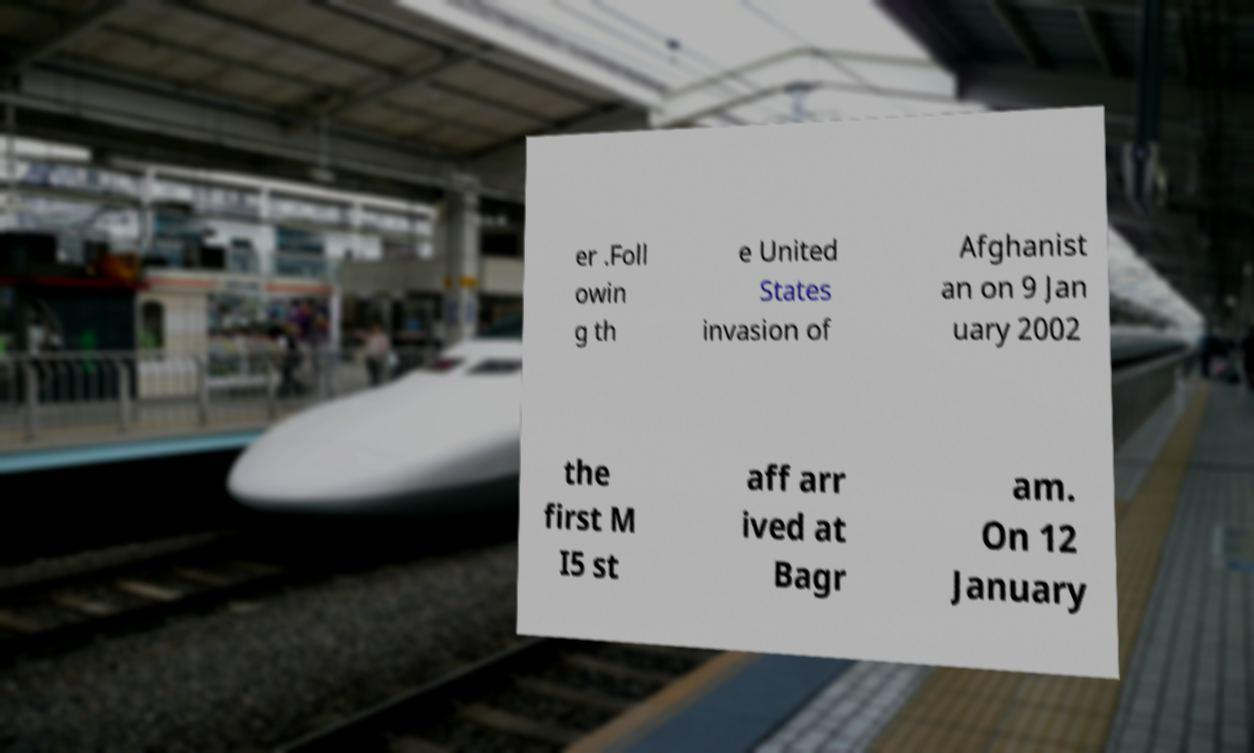For documentation purposes, I need the text within this image transcribed. Could you provide that? er .Foll owin g th e United States invasion of Afghanist an on 9 Jan uary 2002 the first M I5 st aff arr ived at Bagr am. On 12 January 